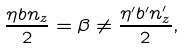<formula> <loc_0><loc_0><loc_500><loc_500>\frac { \eta b n _ { z } } { 2 } = \beta \neq \frac { \eta ^ { \prime } b ^ { \prime } n ^ { \prime } _ { z } } { 2 } ,</formula> 